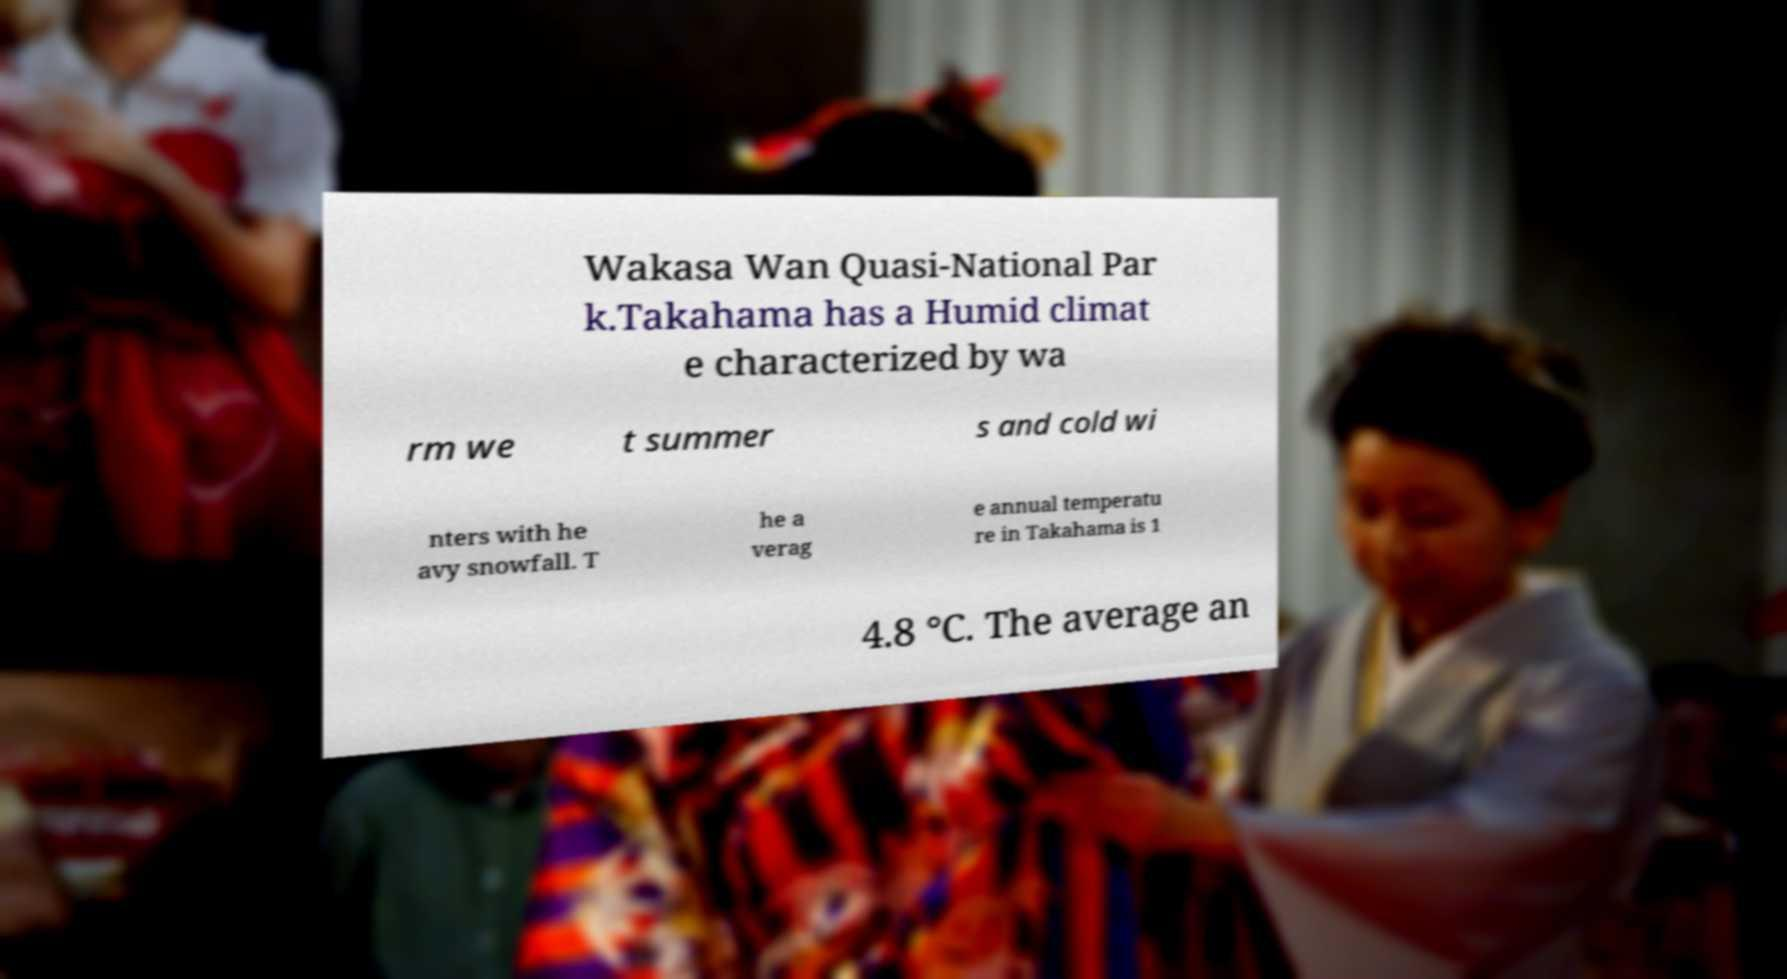Can you accurately transcribe the text from the provided image for me? Wakasa Wan Quasi-National Par k.Takahama has a Humid climat e characterized by wa rm we t summer s and cold wi nters with he avy snowfall. T he a verag e annual temperatu re in Takahama is 1 4.8 °C. The average an 